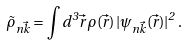Convert formula to latex. <formula><loc_0><loc_0><loc_500><loc_500>\tilde { \rho } _ { n \vec { k } } = \int d ^ { 3 } { \vec { r } } \, \rho ( \vec { r } ) \, | \psi _ { n \vec { k } } ( \vec { r } ) | ^ { 2 } \, .</formula> 